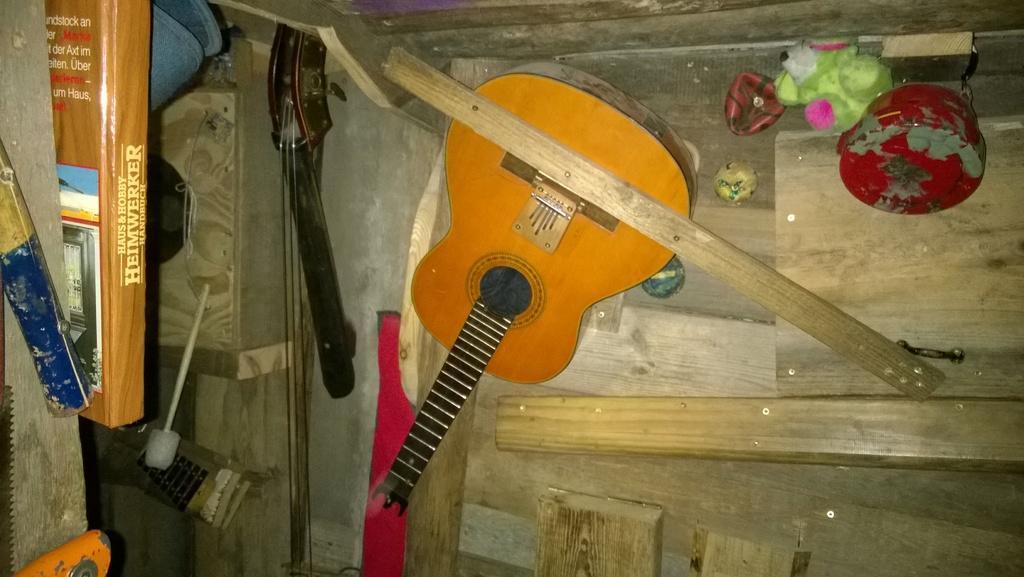Describe this image in one or two sentences. As we can see in the image, there is a wooden door, a guitar and a book. 